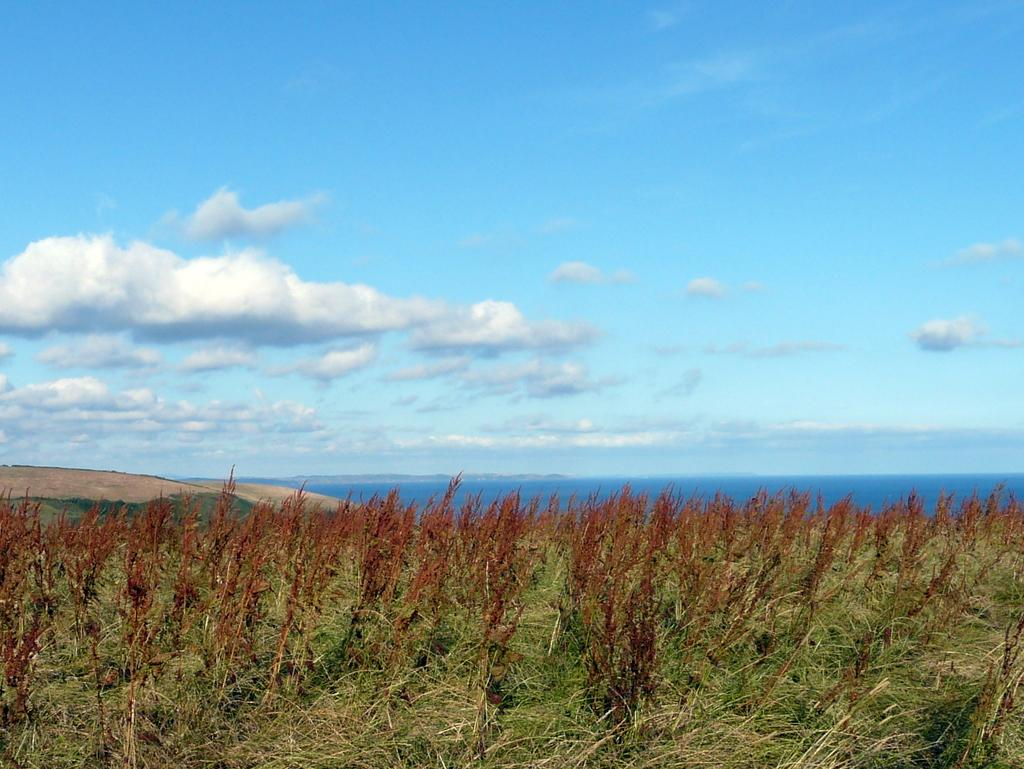What type of vegetation is at the bottom of the image? There is grass and small plants at the bottom of the image. What can be seen behind the grass and small plants? There is water visible behind the grass and small plants. What is visible at the top of the image? The sky is visible at the top of the image. What can be observed in the sky? There are clouds in the sky. What type of shoe is being selected in the middle of the image? There is no shoe or selection process present in the image. What is the middle of the image showing? The middle of the image shows a combination of grass, small plants, and water. 